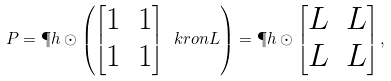Convert formula to latex. <formula><loc_0><loc_0><loc_500><loc_500>P = \P h \odot \left ( \begin{bmatrix} 1 & 1 \\ 1 & 1 \end{bmatrix} \ k r o n L \right ) = \P h \odot \begin{bmatrix} L & L \\ L & L \end{bmatrix} ,</formula> 